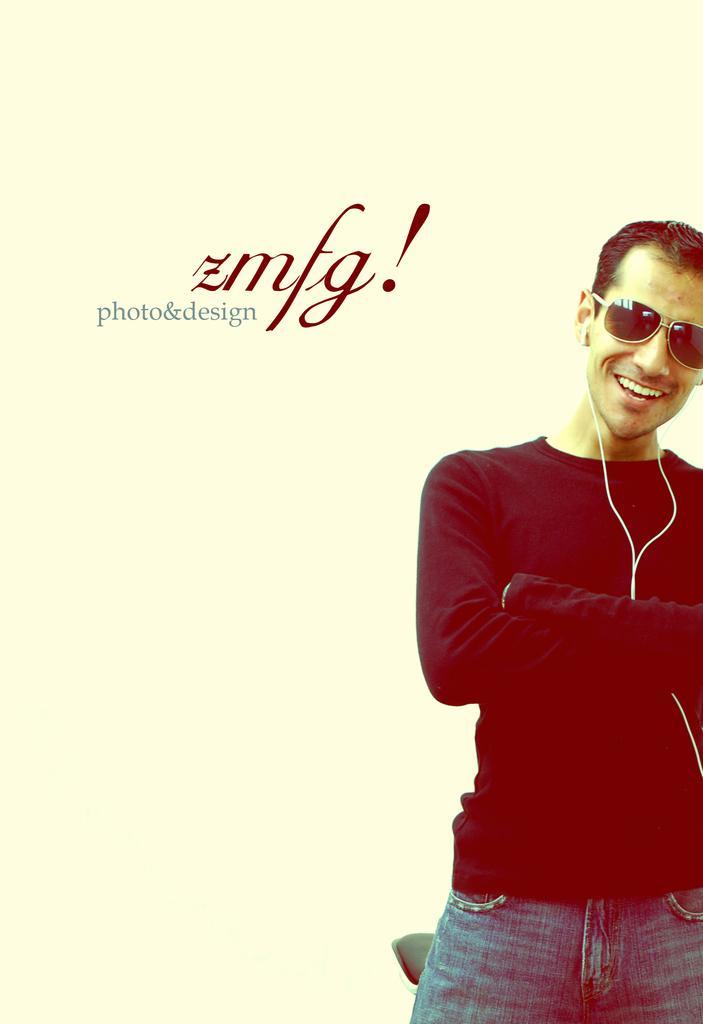How would you summarize this image in a sentence or two? In this picture we can see photo poster of the boy wearing a black t-shirt, standing and smiling. 